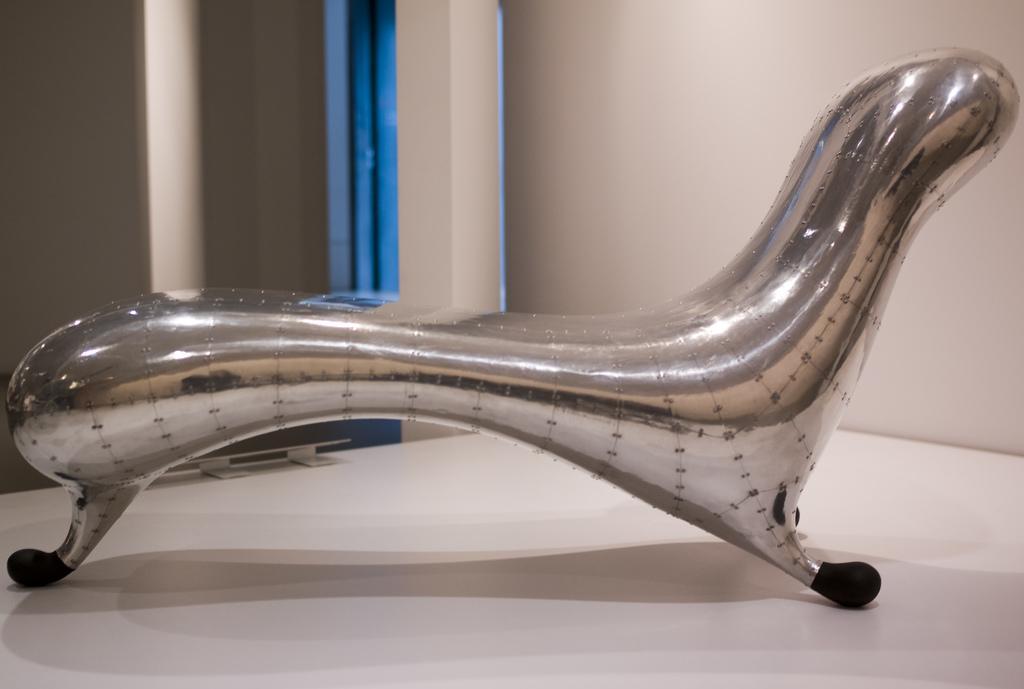Describe this image in one or two sentences. There is a silver chair. In the background there is a wall and a pillar. 